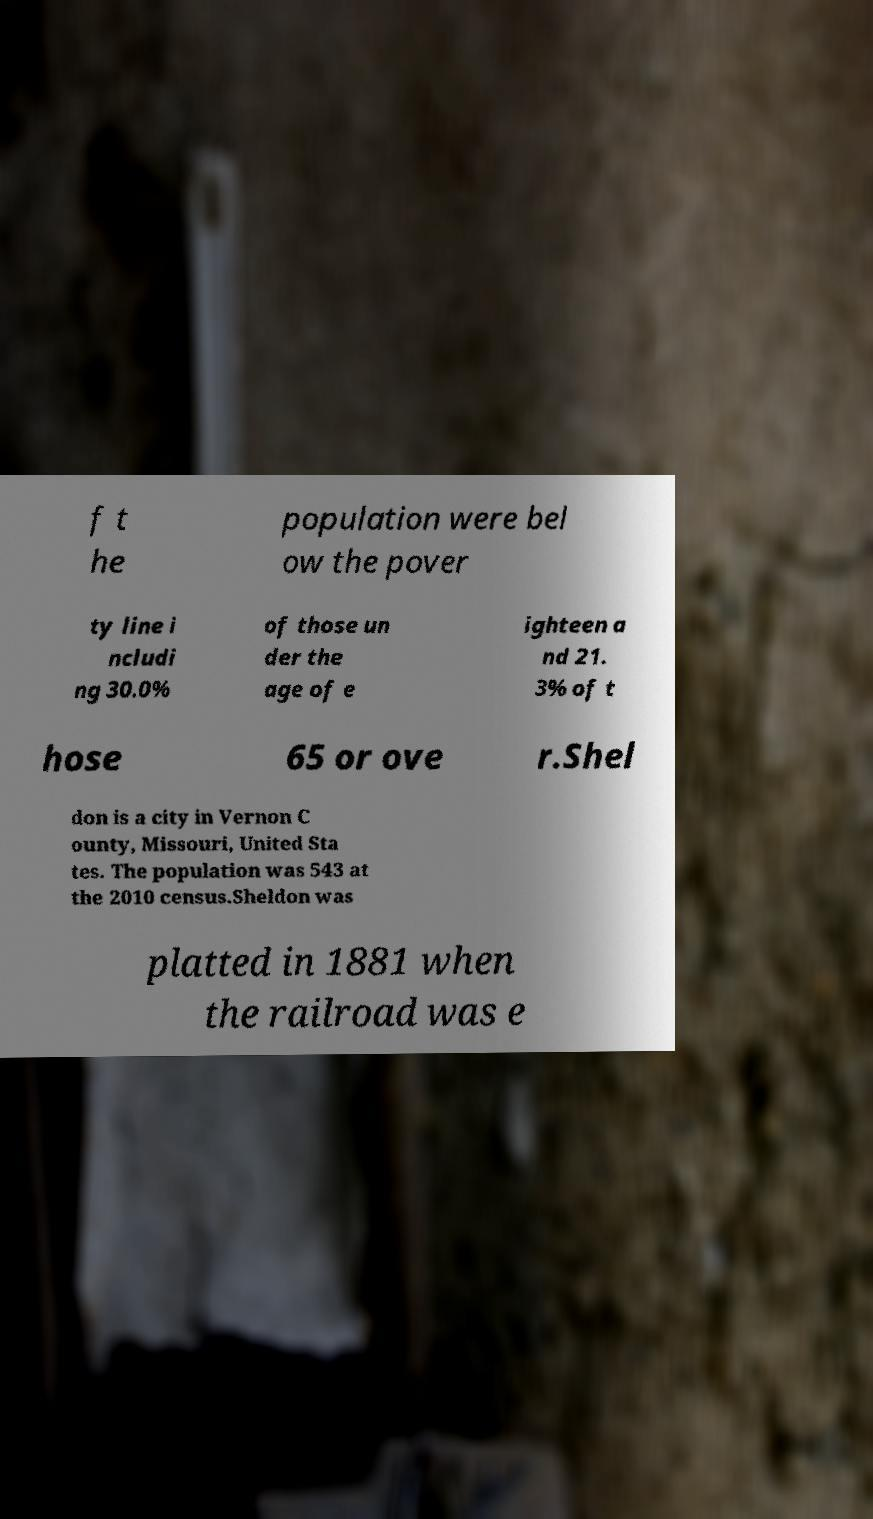I need the written content from this picture converted into text. Can you do that? f t he population were bel ow the pover ty line i ncludi ng 30.0% of those un der the age of e ighteen a nd 21. 3% of t hose 65 or ove r.Shel don is a city in Vernon C ounty, Missouri, United Sta tes. The population was 543 at the 2010 census.Sheldon was platted in 1881 when the railroad was e 